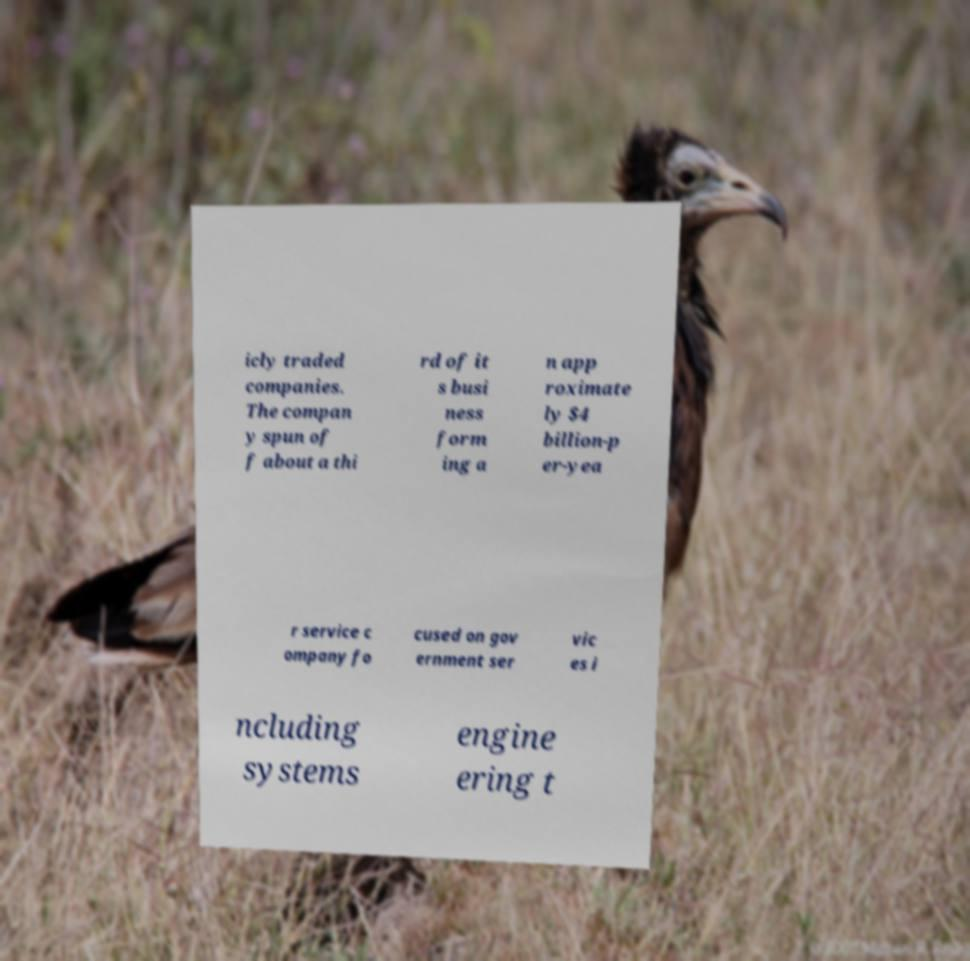Can you accurately transcribe the text from the provided image for me? icly traded companies. The compan y spun of f about a thi rd of it s busi ness form ing a n app roximate ly $4 billion-p er-yea r service c ompany fo cused on gov ernment ser vic es i ncluding systems engine ering t 